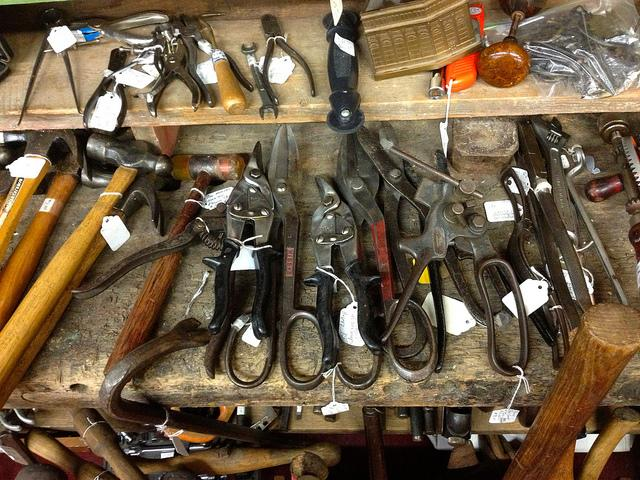Where would these tools be found?

Choices:
A) kitchen
B) store
C) trunk
D) street store 